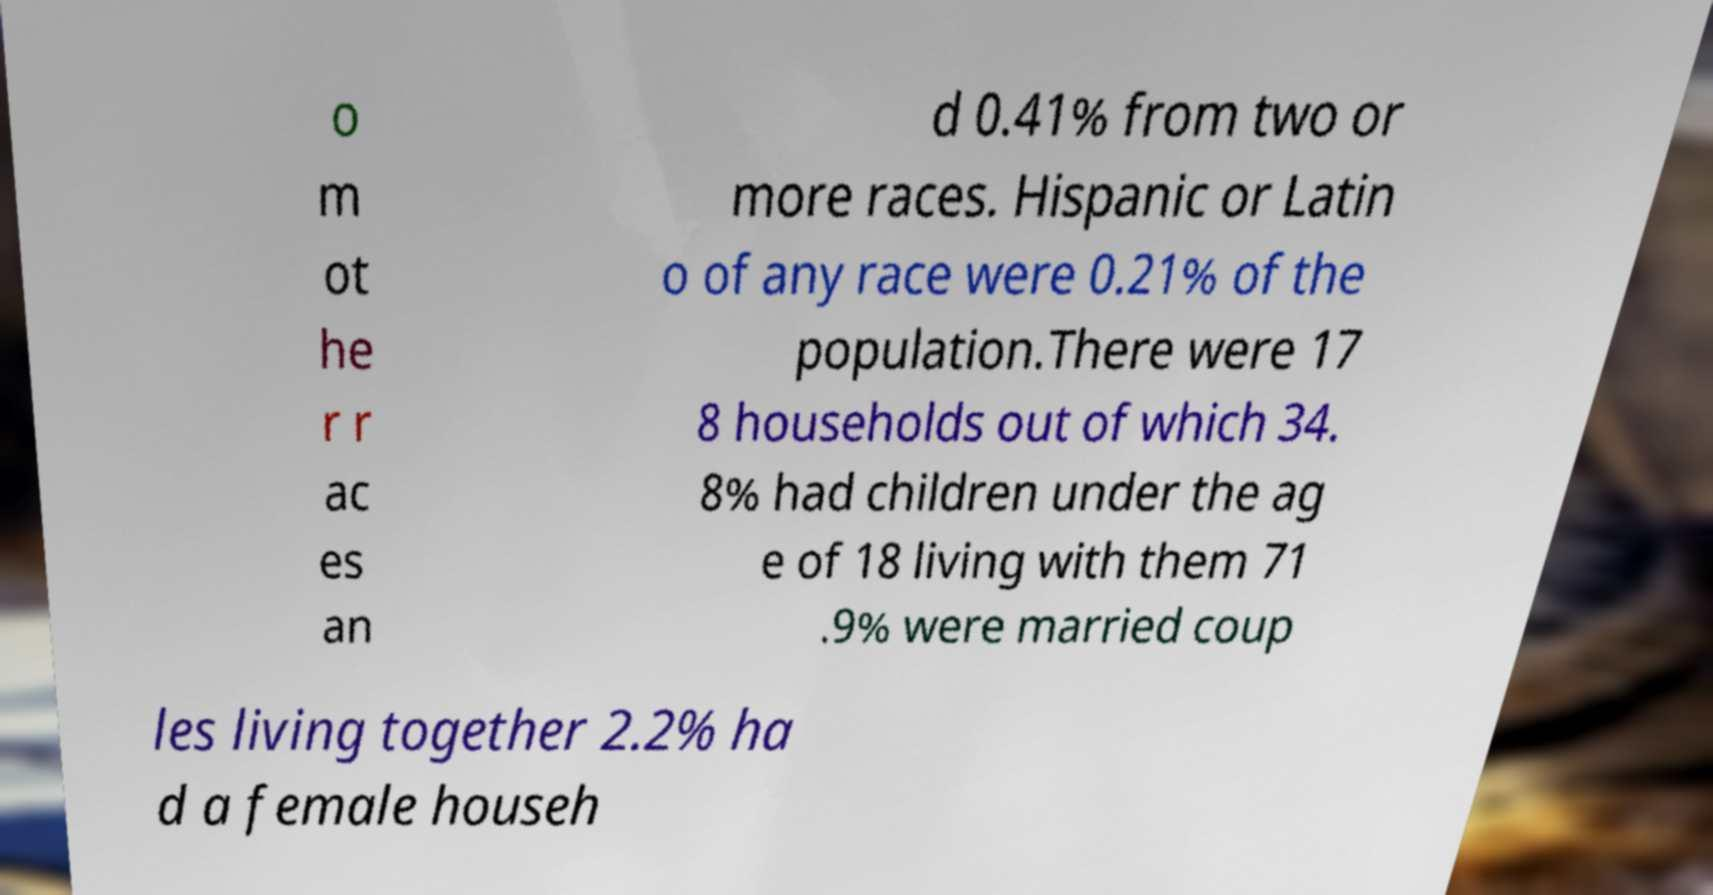For documentation purposes, I need the text within this image transcribed. Could you provide that? o m ot he r r ac es an d 0.41% from two or more races. Hispanic or Latin o of any race were 0.21% of the population.There were 17 8 households out of which 34. 8% had children under the ag e of 18 living with them 71 .9% were married coup les living together 2.2% ha d a female househ 